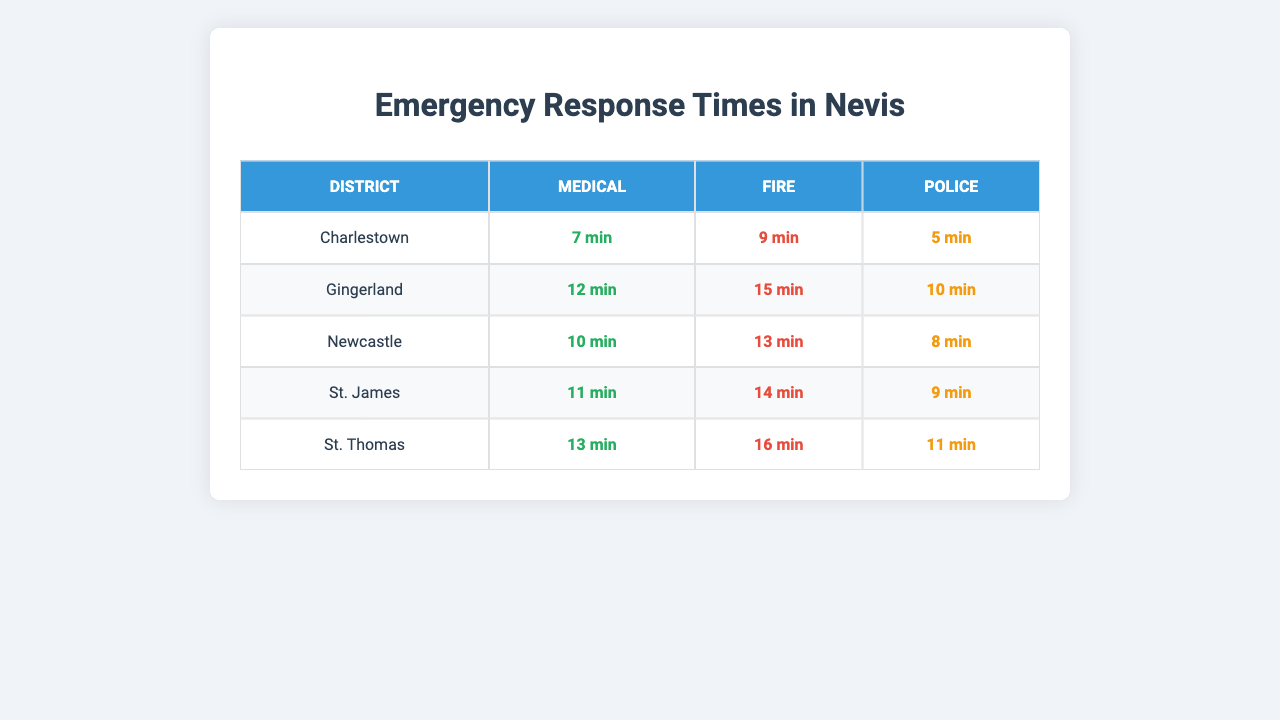What is the emergency response time for Medical emergencies in Charlestown? The table shows that the response time for Medical emergencies in Charlestown is 7 minutes.
Answer: 7 minutes What district has the longest response time for Fire emergencies? By reviewing the table, St. Thomas has the longest response time for Fire emergencies at 16 minutes.
Answer: St. Thomas Is the Police response time in Gingerland shorter than in Newcastle? The table indicates that the Police response time in Gingerland is 10 minutes, while in Newcastle it is 8 minutes; therefore, no, it is not shorter.
Answer: No What is the average response time for Medical emergencies across all districts? Adding the Medical response times: 7 + 12 + 10 + 11 + 13 = 63 minutes; dividing by the number of districts (5) gives an average of 63/5 = 12.6 minutes.
Answer: 12.6 minutes Which emergency type has the fastest response time in Charlestown? In Charlestown, the response times are: Medical 7 minutes, Fire 9 minutes, and Police 5 minutes. The fastest is Police at 5 minutes.
Answer: Police Is the total of Fire response times in Charlestown and Gingerland greater than the total of Fire response times in St. James and St. Thomas combined? The total Fire response time in Charlestown (9 minutes) and Gingerland (15 minutes) is 24 minutes. In contrast, St. James (14 minutes) and St. Thomas (16 minutes) total 30 minutes. Since 24 is less than 30, the statement is true.
Answer: Yes What is the difference in response times for Medical emergencies between St. Thomas and Newcastle? St. Thomas has a Medical response time of 13 minutes, and Newcastle has 10 minutes. The difference is 13 - 10 = 3 minutes.
Answer: 3 minutes Which district has the shortest overall emergency response time? The overall response times for each district are calculated, and Charlestown has the shortest total of 21 minutes (7 + 9 + 5).
Answer: Charlestown How many minutes longer is the Fire response time in Gingerland compared to Police response time in the same district? In Gingerland, the Fire response time is 15 minutes and the Police response time is 10 minutes. The difference is 15 - 10 = 5 minutes longer.
Answer: 5 minutes Does Newcastle have a quicker Medical response than Gingerland? Newcastle's Medical response time is 10 minutes, while Gingerland's is 12 minutes, which means Newcastle is quicker.
Answer: Yes 